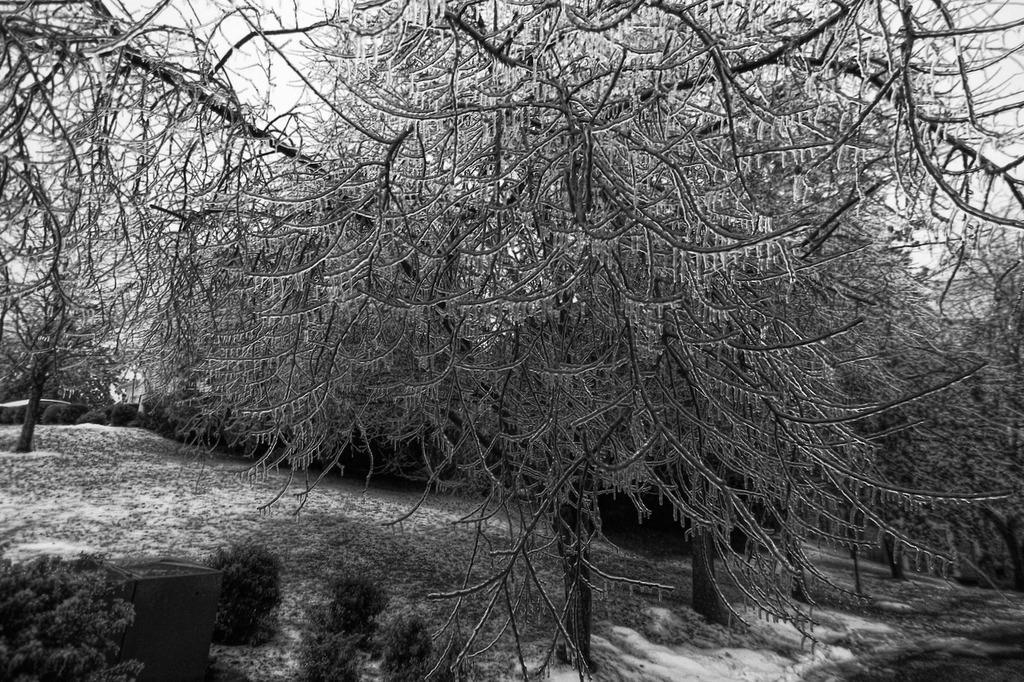How would you summarize this image in a sentence or two? This image consists of many trees. At the bottom, there is a snow. It looks like it is clicked in a forest. 